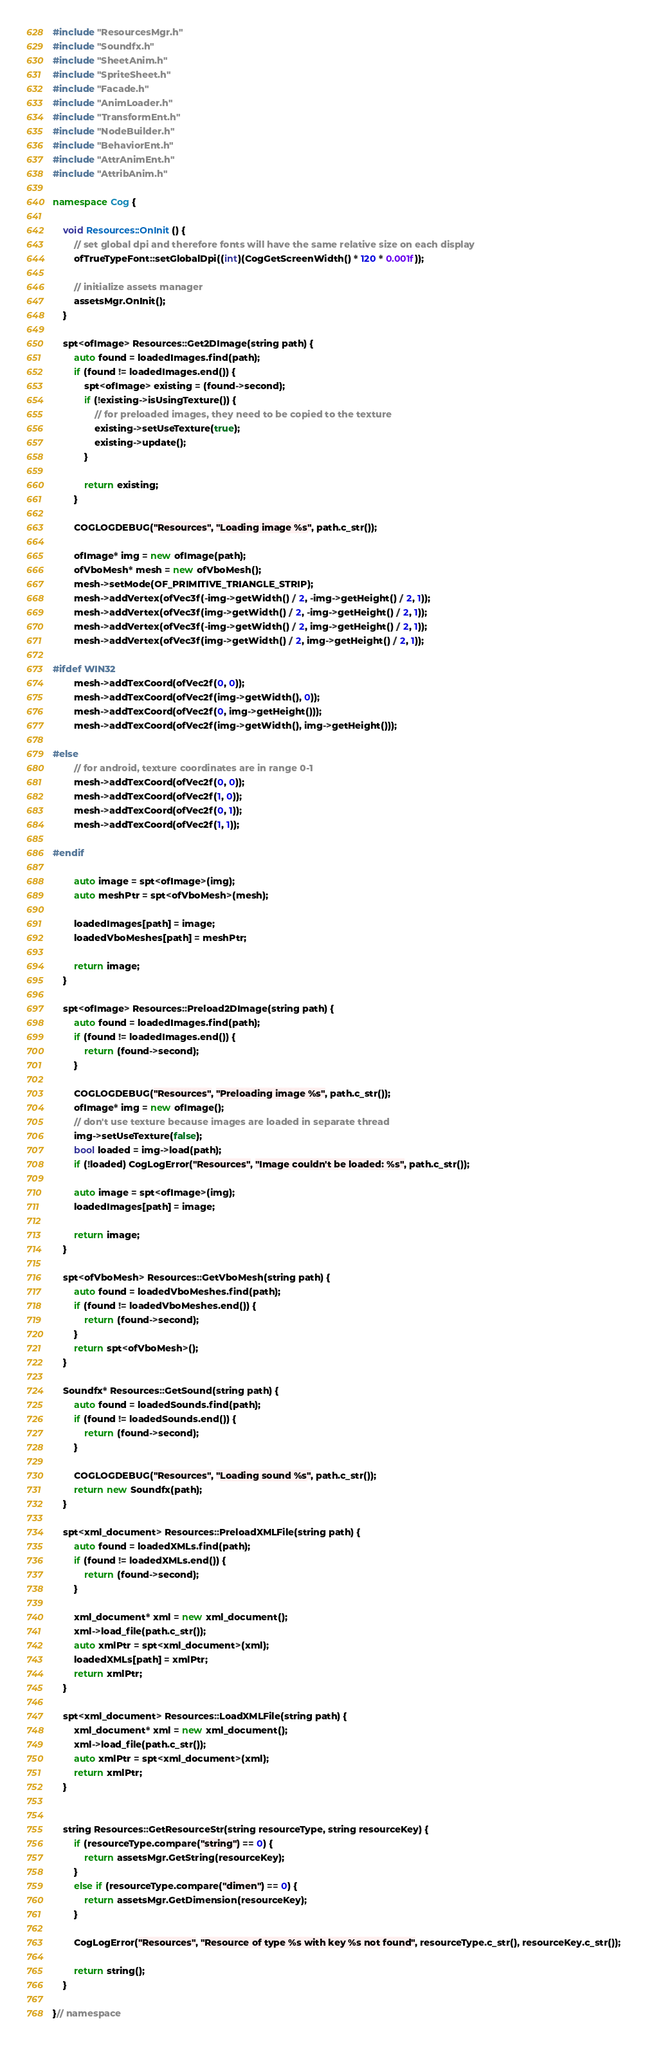Convert code to text. <code><loc_0><loc_0><loc_500><loc_500><_C++_>#include "ResourcesMgr.h"
#include "Soundfx.h"
#include "SheetAnim.h"
#include "SpriteSheet.h"
#include "Facade.h"
#include "AnimLoader.h"
#include "TransformEnt.h"
#include "NodeBuilder.h"
#include "BehaviorEnt.h"
#include "AttrAnimEnt.h"
#include "AttribAnim.h"

namespace Cog {

	void Resources::OnInit() {
		// set global dpi and therefore fonts will have the same relative size on each display
		ofTrueTypeFont::setGlobalDpi((int)(CogGetScreenWidth() * 120 * 0.001f));

		// initialize assets manager
		assetsMgr.OnInit();
	}

	spt<ofImage> Resources::Get2DImage(string path) {
		auto found = loadedImages.find(path);
		if (found != loadedImages.end()) {
			spt<ofImage> existing = (found->second);
			if (!existing->isUsingTexture()) {
				// for preloaded images, they need to be copied to the texture
				existing->setUseTexture(true);
				existing->update();
			}

			return existing;
		}

		COGLOGDEBUG("Resources", "Loading image %s", path.c_str());

		ofImage* img = new ofImage(path); 
		ofVboMesh* mesh = new ofVboMesh();
		mesh->setMode(OF_PRIMITIVE_TRIANGLE_STRIP);
		mesh->addVertex(ofVec3f(-img->getWidth() / 2, -img->getHeight() / 2, 1));
		mesh->addVertex(ofVec3f(img->getWidth() / 2, -img->getHeight() / 2, 1));
		mesh->addVertex(ofVec3f(-img->getWidth() / 2, img->getHeight() / 2, 1));
		mesh->addVertex(ofVec3f(img->getWidth() / 2, img->getHeight() / 2, 1));

#ifdef WIN32
		mesh->addTexCoord(ofVec2f(0, 0));
		mesh->addTexCoord(ofVec2f(img->getWidth(), 0));
		mesh->addTexCoord(ofVec2f(0, img->getHeight()));
		mesh->addTexCoord(ofVec2f(img->getWidth(), img->getHeight()));

#else
		// for android, texture coordinates are in range 0-1
		mesh->addTexCoord(ofVec2f(0, 0));
		mesh->addTexCoord(ofVec2f(1, 0));
		mesh->addTexCoord(ofVec2f(0, 1));
		mesh->addTexCoord(ofVec2f(1, 1));

#endif

		auto image = spt<ofImage>(img);
		auto meshPtr = spt<ofVboMesh>(mesh);

		loadedImages[path] = image;
		loadedVboMeshes[path] = meshPtr;

		return image;
	}

	spt<ofImage> Resources::Preload2DImage(string path) {
		auto found = loadedImages.find(path);
		if (found != loadedImages.end()) {
			return (found->second);
		}

		COGLOGDEBUG("Resources", "Preloading image %s", path.c_str());
		ofImage* img = new ofImage();
		// don't use texture because images are loaded in separate thread
		img->setUseTexture(false);
		bool loaded = img->load(path);
		if (!loaded) CogLogError("Resources", "Image couldn't be loaded: %s", path.c_str());

		auto image = spt<ofImage>(img);
		loadedImages[path] = image;

		return image;
	}

	spt<ofVboMesh> Resources::GetVboMesh(string path) {
		auto found = loadedVboMeshes.find(path);
		if (found != loadedVboMeshes.end()) {
			return (found->second);
		}
		return spt<ofVboMesh>();
	}

	Soundfx* Resources::GetSound(string path) {
		auto found = loadedSounds.find(path);
		if (found != loadedSounds.end()) {
			return (found->second);
		}

		COGLOGDEBUG("Resources", "Loading sound %s", path.c_str());
		return new Soundfx(path);
	}

	spt<xml_document> Resources::PreloadXMLFile(string path) {
		auto found = loadedXMLs.find(path);
		if (found != loadedXMLs.end()) {
			return (found->second);
		}

		xml_document* xml = new xml_document();
		xml->load_file(path.c_str());
		auto xmlPtr = spt<xml_document>(xml);
		loadedXMLs[path] = xmlPtr;
		return xmlPtr;
	}

	spt<xml_document> Resources::LoadXMLFile(string path) {
		xml_document* xml = new xml_document();
		xml->load_file(path.c_str());
		auto xmlPtr = spt<xml_document>(xml);
		return xmlPtr;
	}


	string Resources::GetResourceStr(string resourceType, string resourceKey) {
		if (resourceType.compare("string") == 0) {
			return assetsMgr.GetString(resourceKey);
		}
		else if (resourceType.compare("dimen") == 0) {
			return assetsMgr.GetDimension(resourceKey);
		}

		CogLogError("Resources", "Resource of type %s with key %s not found", resourceType.c_str(), resourceKey.c_str());

		return string();
	}

}// namespace</code> 